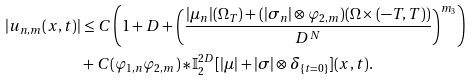<formula> <loc_0><loc_0><loc_500><loc_500>| u _ { n , m } ( x , t ) | & \leq C \left ( 1 + D + \left ( \frac { | \mu _ { n } | ( \Omega _ { T } ) + ( | \sigma _ { n } | \otimes \varphi _ { 2 , m } ) ( \Omega \times ( - T , T ) ) } { D ^ { N } } \right ) ^ { m _ { 3 } } \right ) \\ & + C ( \varphi _ { 1 , n } \varphi _ { 2 , m } ) \ast \mathbb { I } _ { 2 } ^ { 2 D } [ | \mu | + | \sigma | \otimes \delta _ { \{ t = 0 \} } ] ( x , t ) .</formula> 